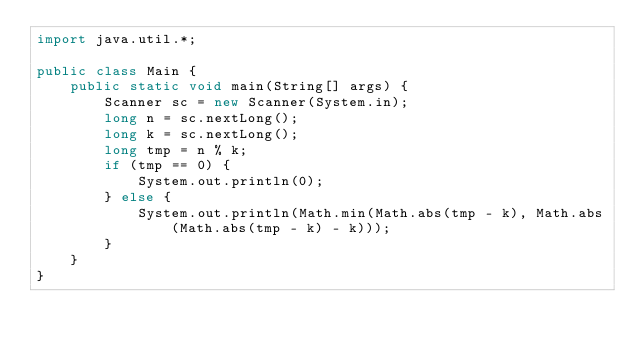<code> <loc_0><loc_0><loc_500><loc_500><_Java_>import java.util.*;

public class Main {
    public static void main(String[] args) {
        Scanner sc = new Scanner(System.in);
        long n = sc.nextLong();
        long k = sc.nextLong();
        long tmp = n % k;
        if (tmp == 0) {
            System.out.println(0);
        } else {
            System.out.println(Math.min(Math.abs(tmp - k), Math.abs(Math.abs(tmp - k) - k)));
        }
    }
}
</code> 